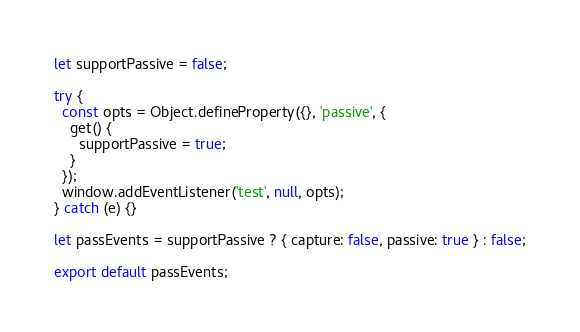Convert code to text. <code><loc_0><loc_0><loc_500><loc_500><_JavaScript_>let supportPassive = false;

try {
  const opts = Object.defineProperty({}, 'passive', {
    get() {
      supportPassive = true;
    }
  });
  window.addEventListener('test', null, opts);
} catch (e) {}

let passEvents = supportPassive ? { capture: false, passive: true } : false;

export default passEvents;
</code> 